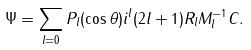Convert formula to latex. <formula><loc_0><loc_0><loc_500><loc_500>\Psi = \sum _ { l = 0 } P _ { l } ( \cos \theta ) i ^ { l } ( 2 l + 1 ) R _ { l } M _ { l } ^ { - 1 } C .</formula> 